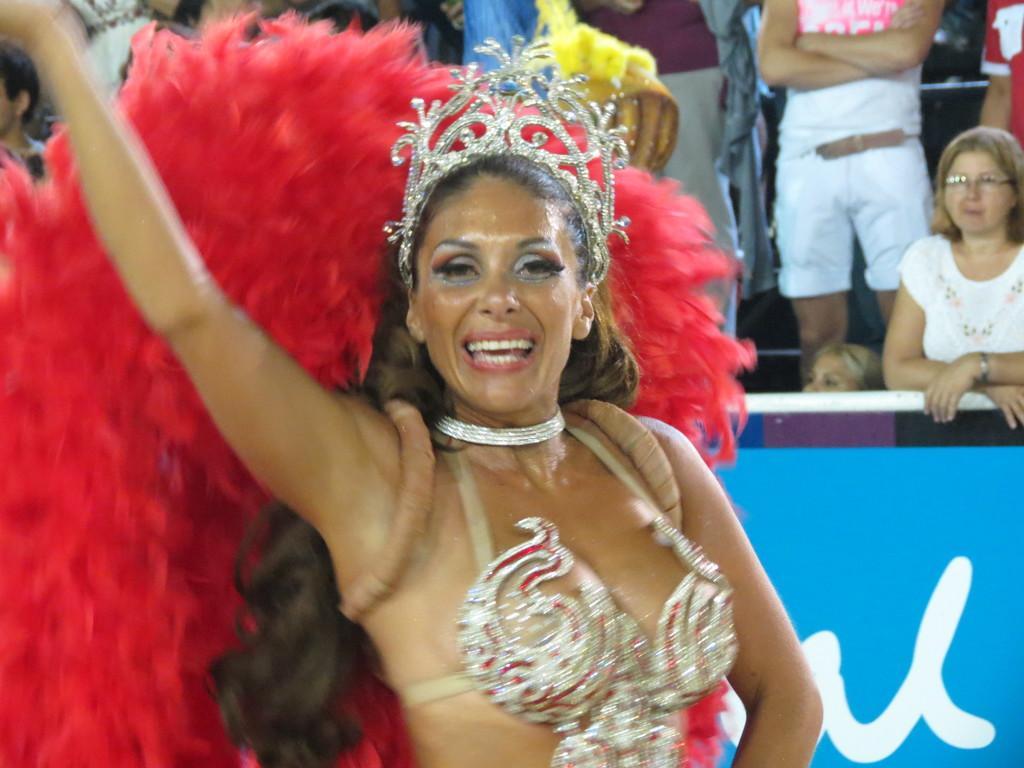In one or two sentences, can you explain what this image depicts? In this image we can see a lady wearing a costume. In the background of the image there are people standing. There is a blue color board with some text on it. 